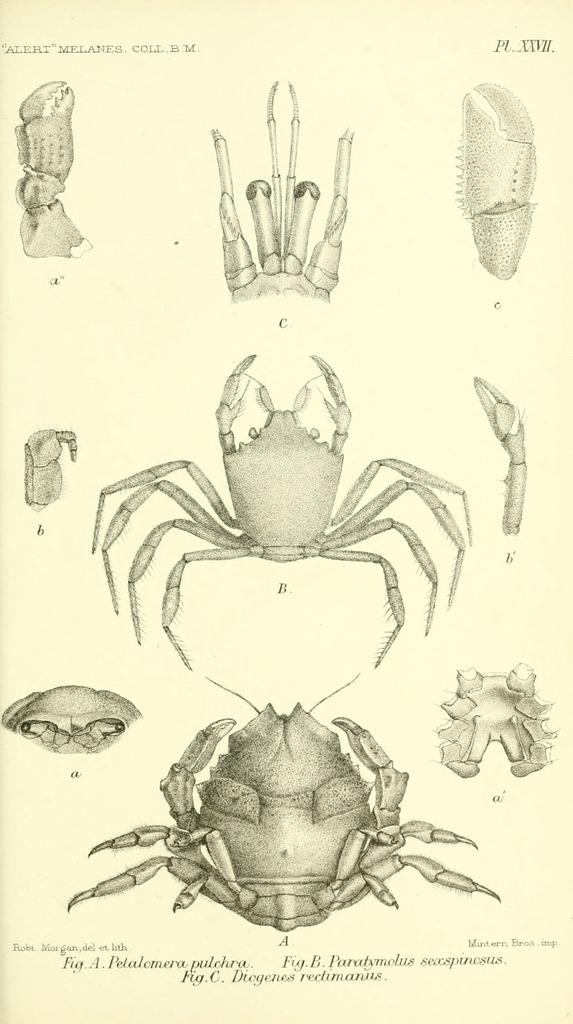What type of visual is the image? The image is a poster. What elements are present on the poster? The poster contains texts and paintings of two insects. Are there any illustrations of insect parts on the poster? Yes, the poster includes illustrations of insect parts. What is the background color of the poster? The background color of the poster is cream. Can you see a monkey or a goat on the poster? No, there are no monkeys or goats depicted on the poster; it features paintings of insects and illustrations of insect parts. Is there a bridge shown on the poster? No, there is no bridge present on the poster. 